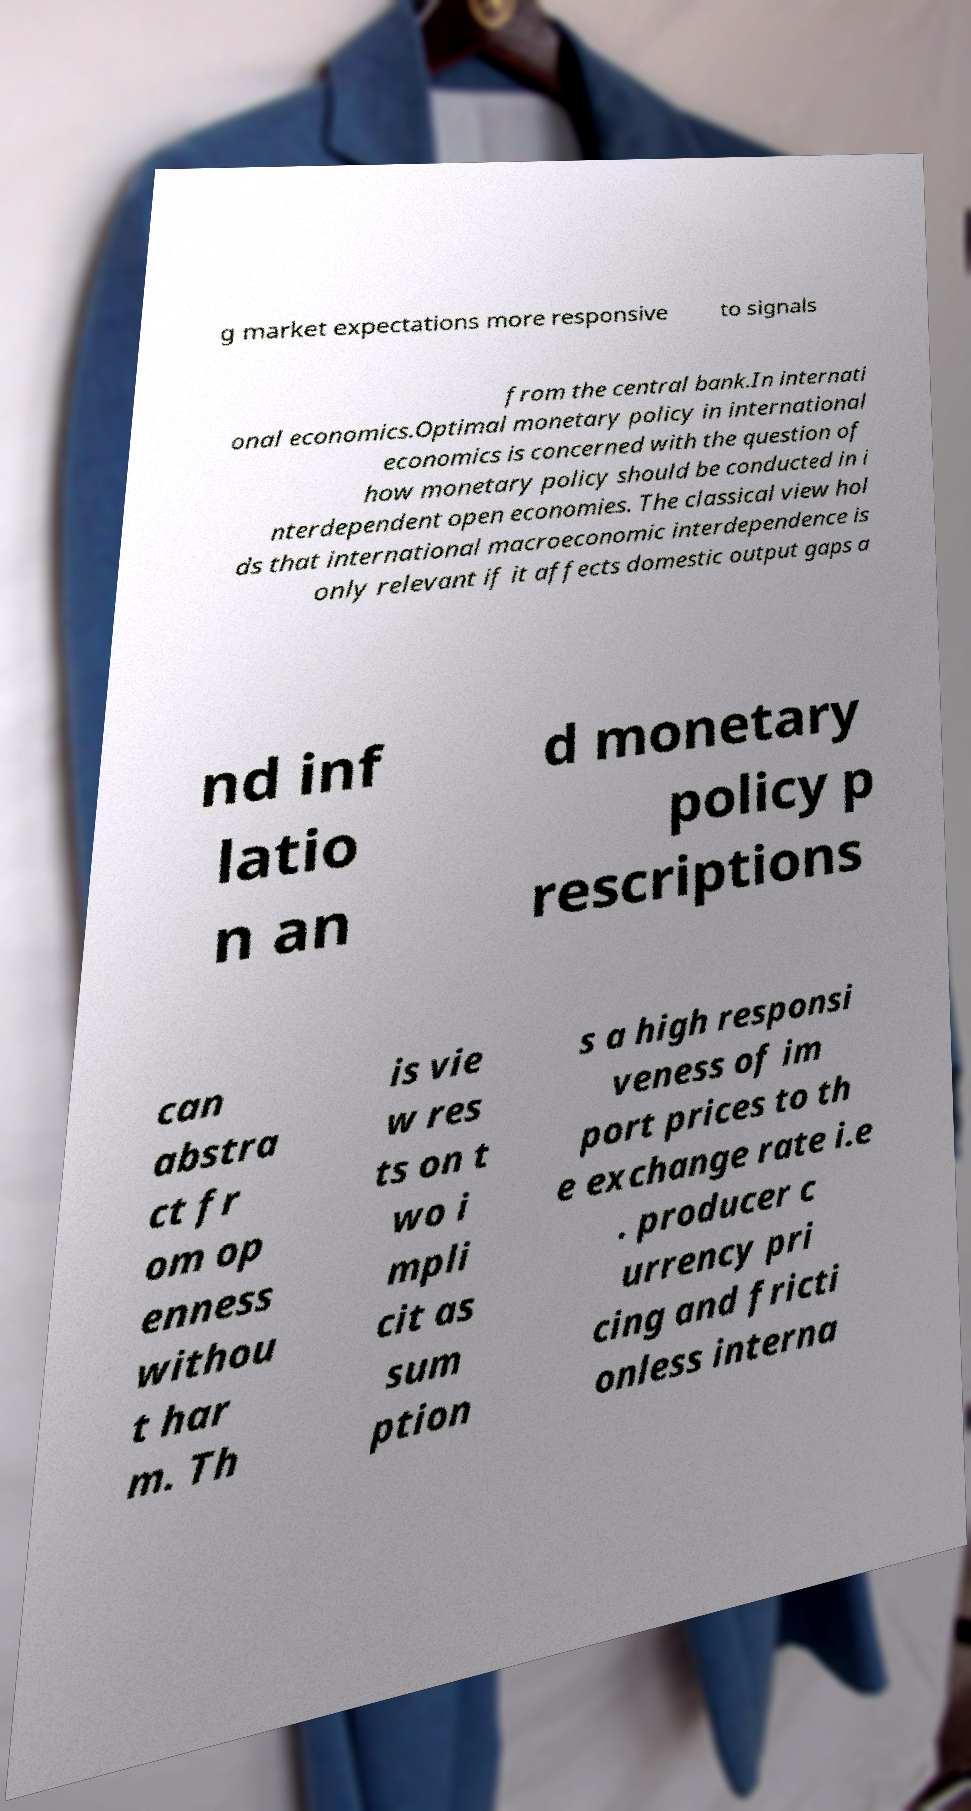For documentation purposes, I need the text within this image transcribed. Could you provide that? g market expectations more responsive to signals from the central bank.In internati onal economics.Optimal monetary policy in international economics is concerned with the question of how monetary policy should be conducted in i nterdependent open economies. The classical view hol ds that international macroeconomic interdependence is only relevant if it affects domestic output gaps a nd inf latio n an d monetary policy p rescriptions can abstra ct fr om op enness withou t har m. Th is vie w res ts on t wo i mpli cit as sum ption s a high responsi veness of im port prices to th e exchange rate i.e . producer c urrency pri cing and fricti onless interna 